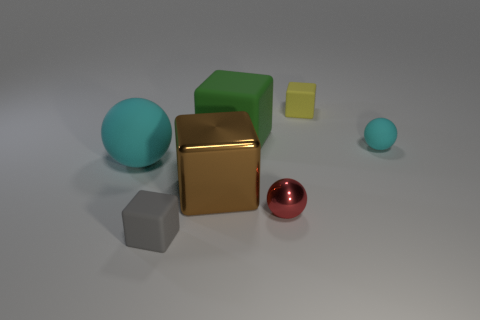What number of spheres are big green things or small cyan matte objects?
Your response must be concise. 1. The other block that is the same size as the green block is what color?
Your response must be concise. Brown. How many cyan rubber objects are in front of the tiny cyan matte thing and on the right side of the small gray rubber object?
Offer a very short reply. 0. What material is the big sphere?
Ensure brevity in your answer.  Rubber. What number of objects are either yellow matte cylinders or yellow objects?
Give a very brief answer. 1. Do the cyan matte sphere that is on the right side of the large metal thing and the cyan object on the left side of the small yellow rubber thing have the same size?
Offer a terse response. No. How many other things are there of the same size as the red metal object?
Your answer should be compact. 3. What number of things are matte spheres that are on the right side of the brown thing or small things that are to the right of the big rubber cube?
Ensure brevity in your answer.  3. Does the brown cube have the same material as the cyan sphere on the right side of the yellow object?
Your response must be concise. No. What number of other objects are the same shape as the big cyan rubber object?
Ensure brevity in your answer.  2. 